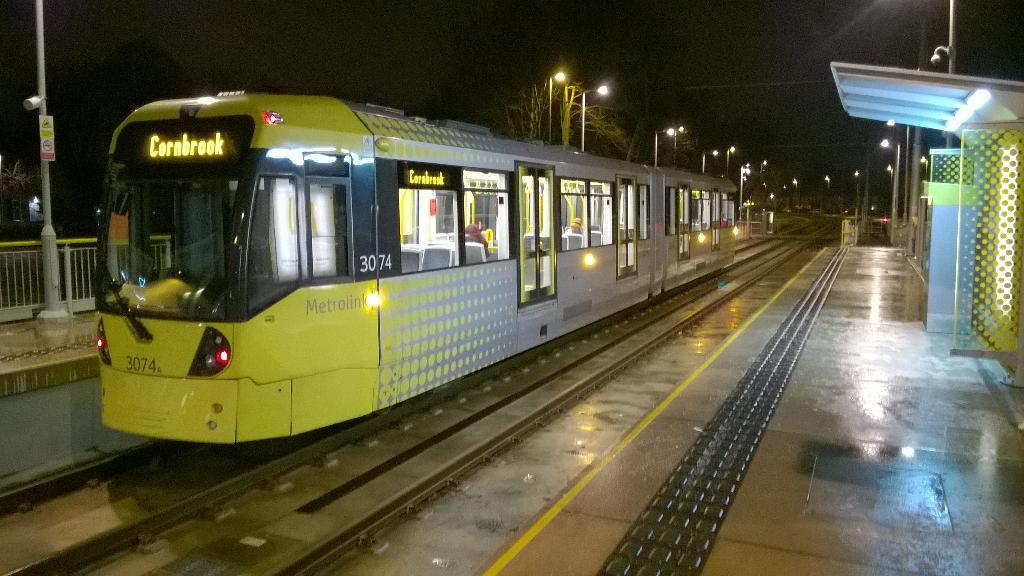<image>
Share a concise interpretation of the image provided. A train at a station going to Cornbrook. 